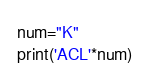Convert code to text. <code><loc_0><loc_0><loc_500><loc_500><_Python_>num="K"
print('ACL'*num)</code> 